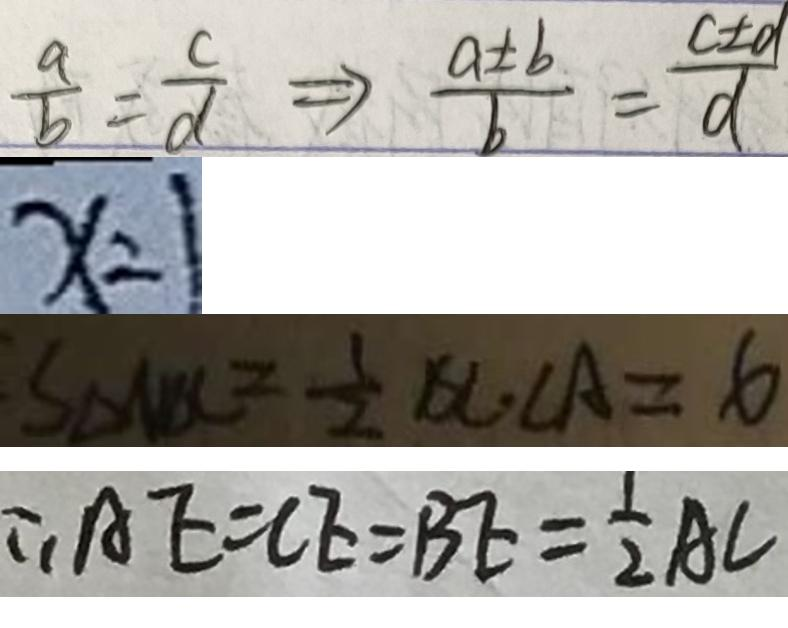Convert formula to latex. <formula><loc_0><loc_0><loc_500><loc_500>\frac { a } { b } = \frac { c } { d } \Rightarrow \frac { a \pm b } { b } = \frac { c \pm d } { d } 
 x = 1 
 S _ { \Delta A B C } = \frac { 1 } { 2 } B C \cdot C A = 6 
 \therefore A E = C E = B E = \frac { 1 } { 2 } A C</formula> 